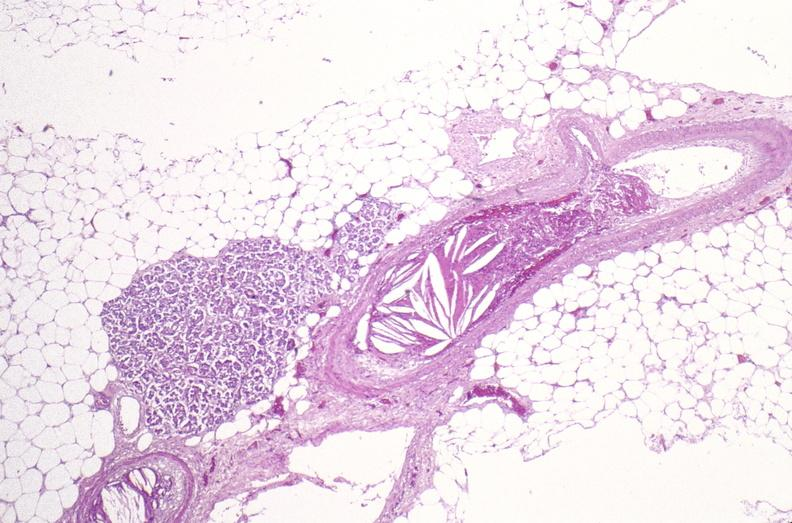what is present?
Answer the question using a single word or phrase. Muscle 